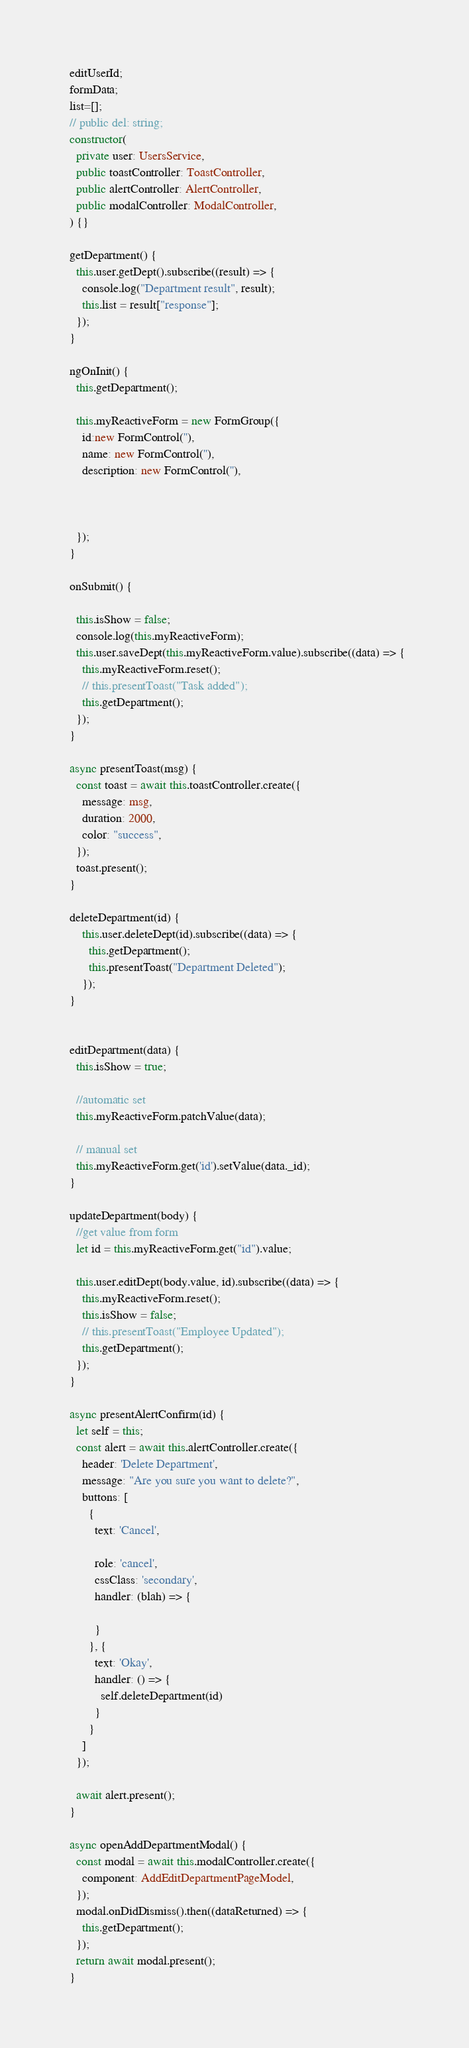Convert code to text. <code><loc_0><loc_0><loc_500><loc_500><_TypeScript_>  editUserId;
  formData;
  list=[];
  // public del: string;
  constructor(
    private user: UsersService,
    public toastController: ToastController,
    public alertController: AlertController,
    public modalController: ModalController,
  ) {}

  getDepartment() {
    this.user.getDept().subscribe((result) => {
      console.log("Department result", result);
      this.list = result["response"];
    });
  }

  ngOnInit() {
    this.getDepartment();
    
    this.myReactiveForm = new FormGroup({
      id:new FormControl(''),
      name: new FormControl(''),
      description: new FormControl(''),
    
      

    });
  }

  onSubmit() {
    
    this.isShow = false;
    console.log(this.myReactiveForm);
    this.user.saveDept(this.myReactiveForm.value).subscribe((data) => {
      this.myReactiveForm.reset();
      // this.presentToast("Task added");
      this.getDepartment();
    });
  }

  async presentToast(msg) {
    const toast = await this.toastController.create({
      message: msg,
      duration: 2000,
      color: "success",
    });
    toast.present();
  }

  deleteDepartment(id) {
      this.user.deleteDept(id).subscribe((data) => {
        this.getDepartment();
        this.presentToast("Department Deleted");
      });
  }

 
  editDepartment(data) {
    this.isShow = true;

    //automatic set
    this.myReactiveForm.patchValue(data);

    // manual set 
    this.myReactiveForm.get('id').setValue(data._id);
  }

  updateDepartment(body) {
    //get value from form
    let id = this.myReactiveForm.get("id").value;

    this.user.editDept(body.value, id).subscribe((data) => {
      this.myReactiveForm.reset();
      this.isShow = false;
      // this.presentToast("Employee Updated");
      this.getDepartment();   
    });
  }

  async presentAlertConfirm(id) {
    let self = this;
    const alert = await this.alertController.create({
      header: 'Delete Department',
      message: "Are you sure you want to delete?",
      buttons: [
        {
          text: 'Cancel',

          role: 'cancel',
          cssClass: 'secondary',
          handler: (blah) => {
            
          }
        }, {
          text: 'Okay',
          handler: () => {
            self.deleteDepartment(id)
          }
        }
      ]
    });

    await alert.present();
  }

  async openAddDepartmentModal() {
    const modal = await this.modalController.create({
      component: AddEditDepartmentPageModel,
    });
    modal.onDidDismiss().then((dataReturned) => {
      this.getDepartment();
    });
    return await modal.present();
  }
</code> 